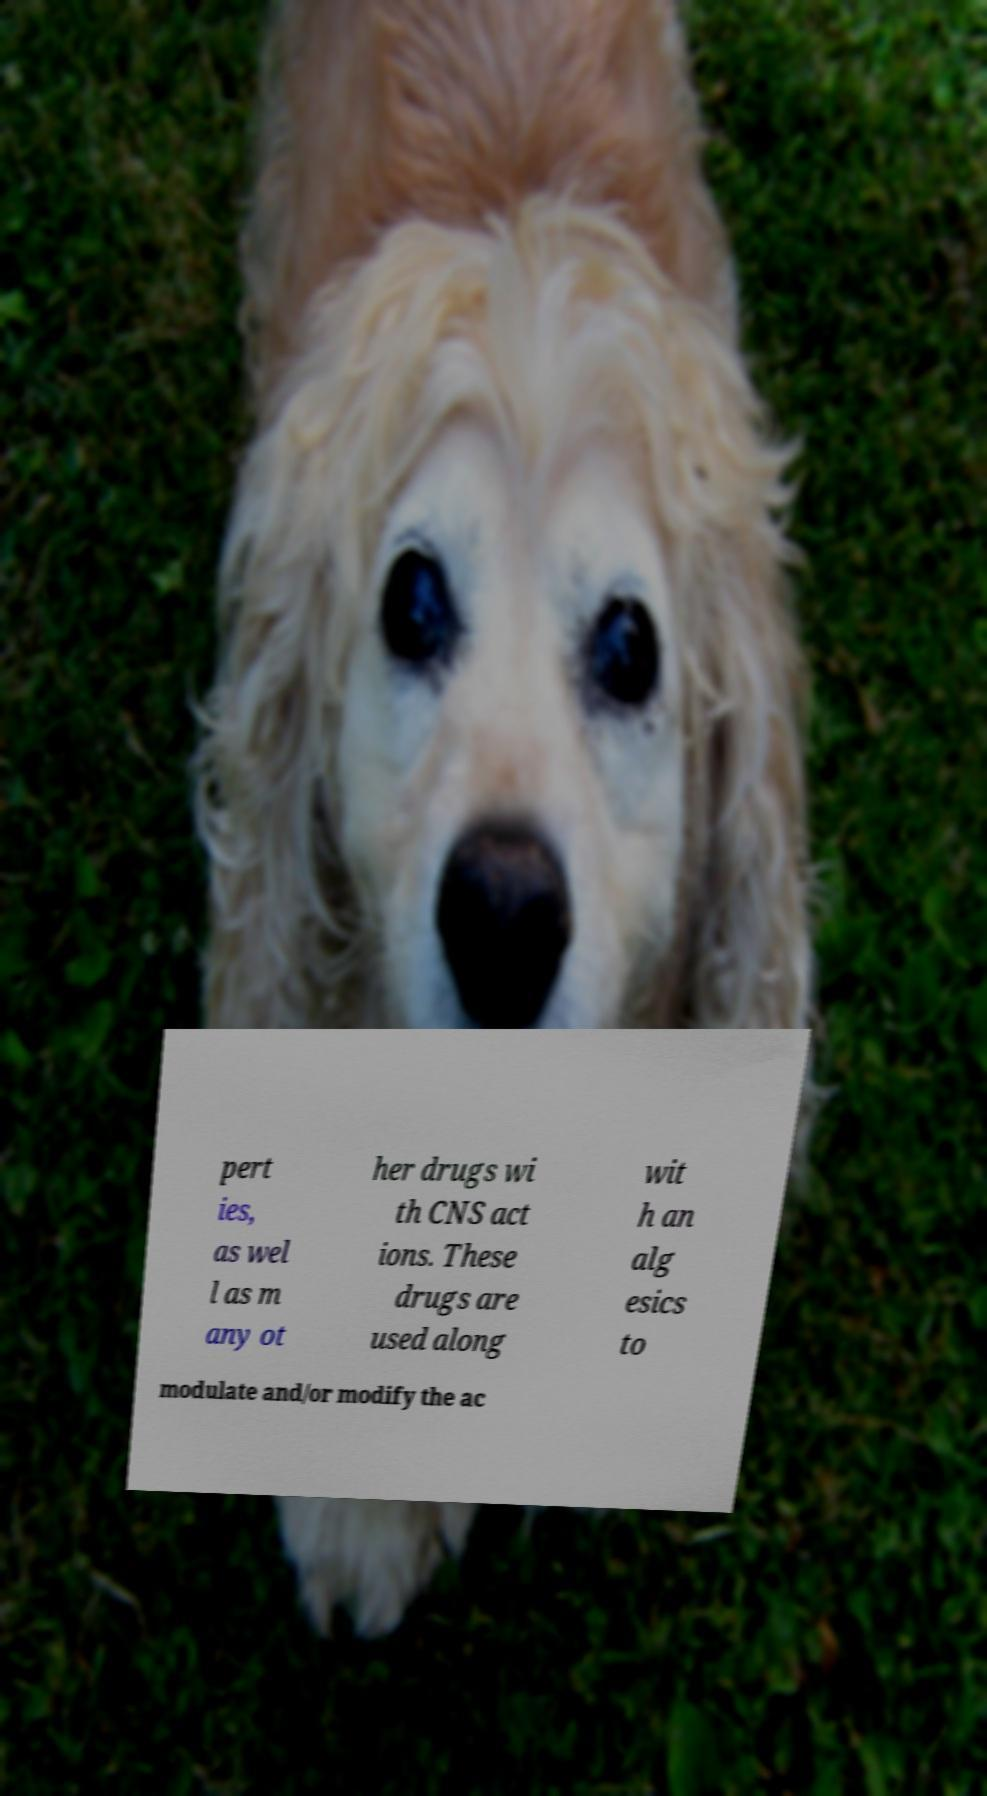Please read and relay the text visible in this image. What does it say? pert ies, as wel l as m any ot her drugs wi th CNS act ions. These drugs are used along wit h an alg esics to modulate and/or modify the ac 